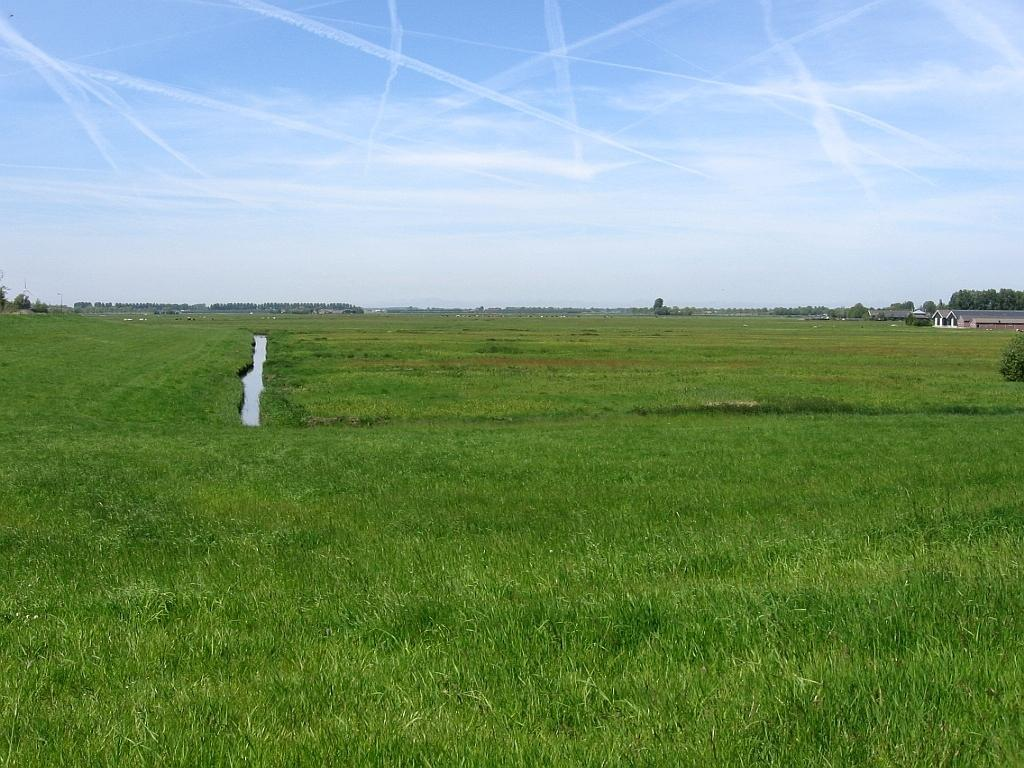What is the main subject of the image? The main subject of the image is a crop. What can be seen in the distance beyond the crop? There are houses and trees visible in the distance. What is visible in the sky in the image? The sky is visible in the image, and clouds are present. What type of yam is growing in the pocket of the person in the image? There is no person or pocket visible in the image; it features a crop, houses, trees, sky, and clouds. 